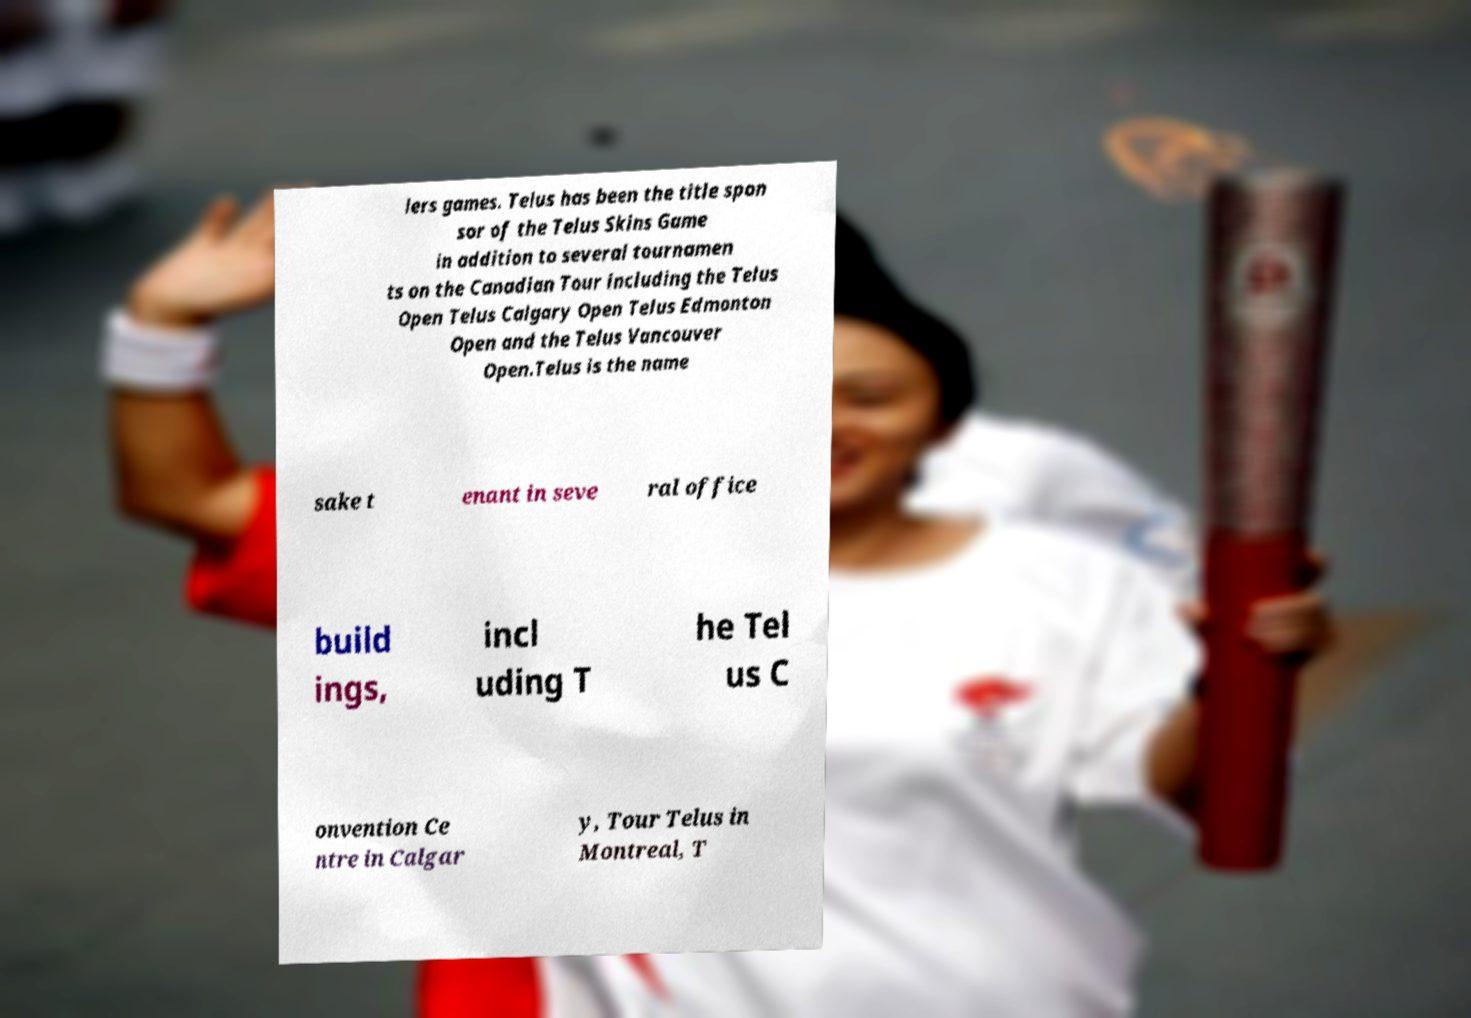Can you accurately transcribe the text from the provided image for me? lers games. Telus has been the title spon sor of the Telus Skins Game in addition to several tournamen ts on the Canadian Tour including the Telus Open Telus Calgary Open Telus Edmonton Open and the Telus Vancouver Open.Telus is the name sake t enant in seve ral office build ings, incl uding T he Tel us C onvention Ce ntre in Calgar y, Tour Telus in Montreal, T 